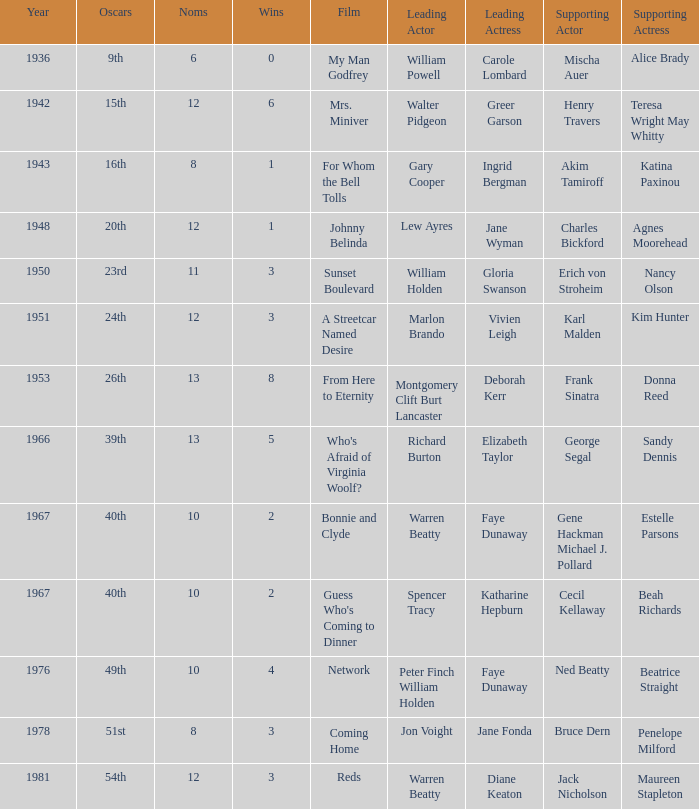Who was the supporting actress in "For Whom the Bell Tolls"? Katina Paxinou. 